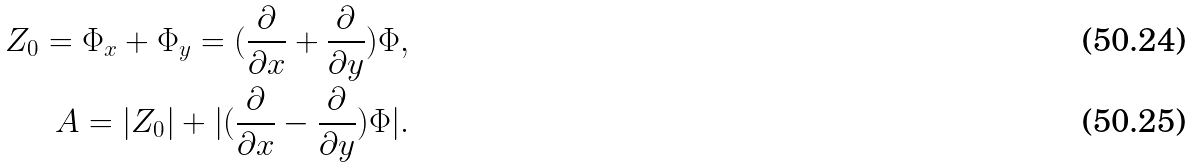Convert formula to latex. <formula><loc_0><loc_0><loc_500><loc_500>Z _ { 0 } = \Phi _ { x } + \Phi _ { y } = ( \frac { \partial } { \partial x } + \frac { \partial } { \partial y } ) \Phi , \\ A = | Z _ { 0 } | + | ( \frac { \partial } { \partial x } - \frac { \partial } { \partial y } ) \Phi | .</formula> 